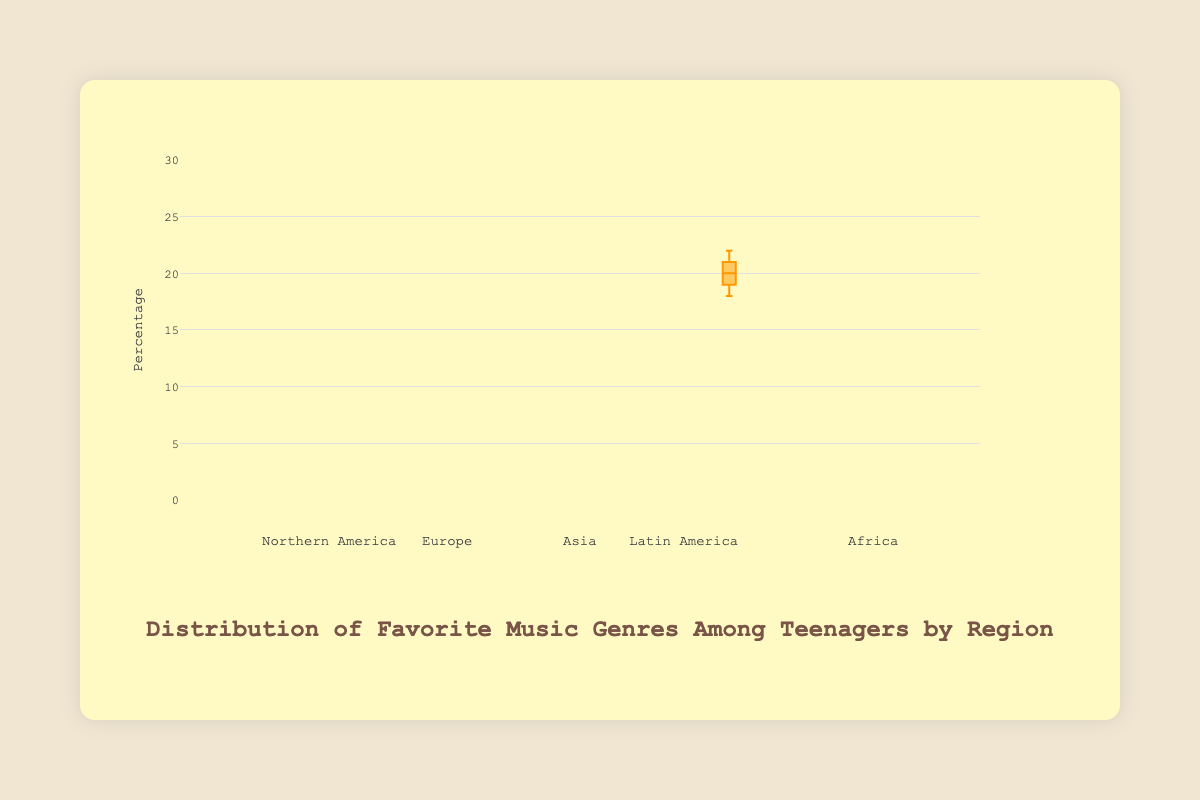What is the title of the figure? The title of the figure is displayed prominently at the top of the chart in larger font size.
Answer: Distribution of Favorite Music Genres Among Teenagers by Region What does the y-axis represent? The y-axis represents the percentage, as indicated by the title on the y-axis on the left side of the chart.
Answer: Percentage Which genre has the highest median value in Northern America? For Northern America, the highest median value represents the middle value of the data points in the 'Hip-Hop' category, as represented by the horizontal line in the 'Hip-Hop' box.
Answer: Hip-Hop What is the interquartile range (IQR) for Pop music in Asia? The IQR can be found by subtracting the first quartile (Q1) value from the third quartile (Q3) value in the Pop music box for Asia. The Q3 value is around 24 and the Q1 value is around 22.
Answer: 2 Which region has the lowest overall median value for Classical music? To find the region with the lowest median value for Classical music, compare the horizontal lines in the boxes marked Classical music for each region, noting that Northern America has the lowest median.
Answer: Northern America What is the median value for Electronic music in Europe? The median is represented by the line within the boxplot for Electronic music in Europe. Here, the median is seen to be 14.5.
Answer: 14.5 Compare the spread of data for Rock music between Europe and Africa. Which region has a wider spread? The spread of data can be assessed by the length of the boxes. For Rock music, Europe has wider boxes indicating more data spread than those in Africa.
Answer: Europe Which music genre has the highest median in Africa? Identify the highest median value by looking at the longest horizontal line within the boxes under Africa. Hip-Hop has the highest median.
Answer: Hip-Hop Are there any regions where the median value of Pop music is the same? Which ones? By checking the median lines in the boxes for Pop music across different regions, we find that the median for both Northern America and Europe is the same at 20.
Answer: Northern America, Europe In Latin America, which music genre has the smallest interquartile range? For Latin America, compare the lengths of the boxes for each genre. 'Hip-Hop' has the smallest interquartile range as its box is the shortest.
Answer: Hip-Hop 